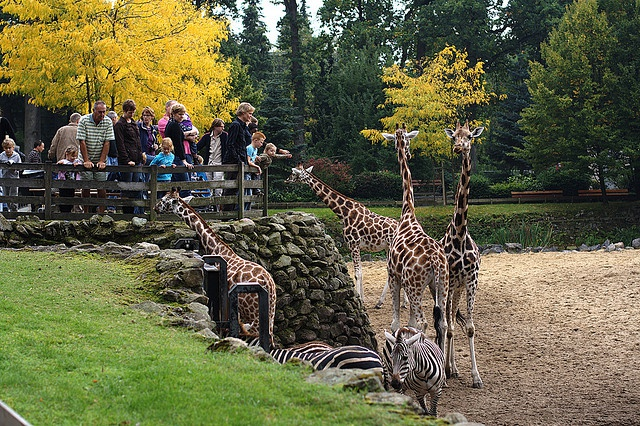Describe the objects in this image and their specific colors. I can see giraffe in gold, black, gray, maroon, and darkgray tones, giraffe in gold, black, gray, and darkgray tones, people in gold, black, gray, darkgreen, and navy tones, giraffe in gold, black, darkgray, maroon, and gray tones, and giraffe in gold, black, maroon, gray, and lightgray tones in this image. 